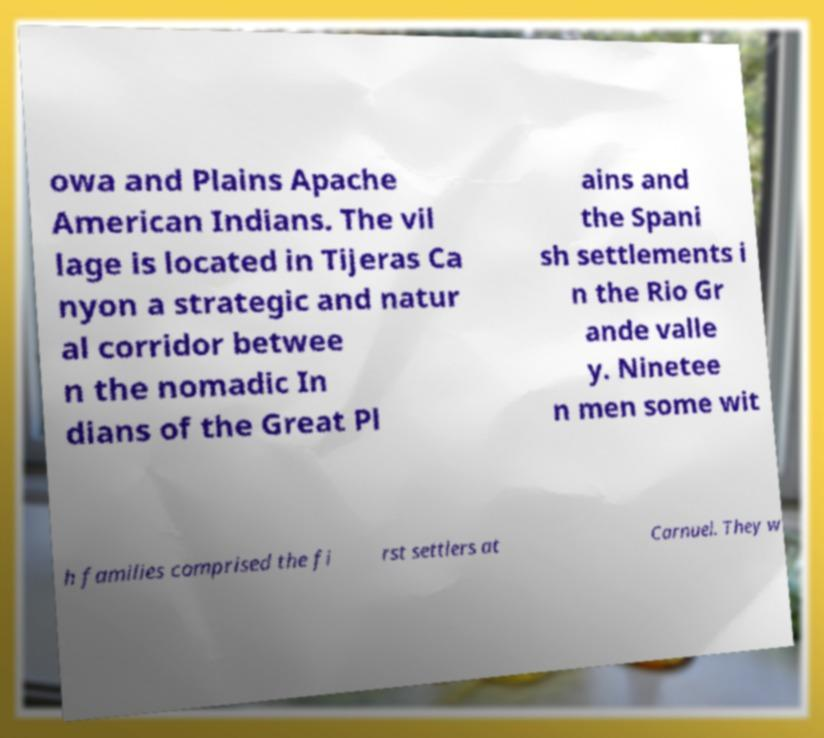There's text embedded in this image that I need extracted. Can you transcribe it verbatim? owa and Plains Apache American Indians. The vil lage is located in Tijeras Ca nyon a strategic and natur al corridor betwee n the nomadic In dians of the Great Pl ains and the Spani sh settlements i n the Rio Gr ande valle y. Ninetee n men some wit h families comprised the fi rst settlers at Carnuel. They w 